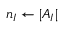<formula> <loc_0><loc_0><loc_500><loc_500>n _ { I } \leftarrow | A _ { I } |</formula> 